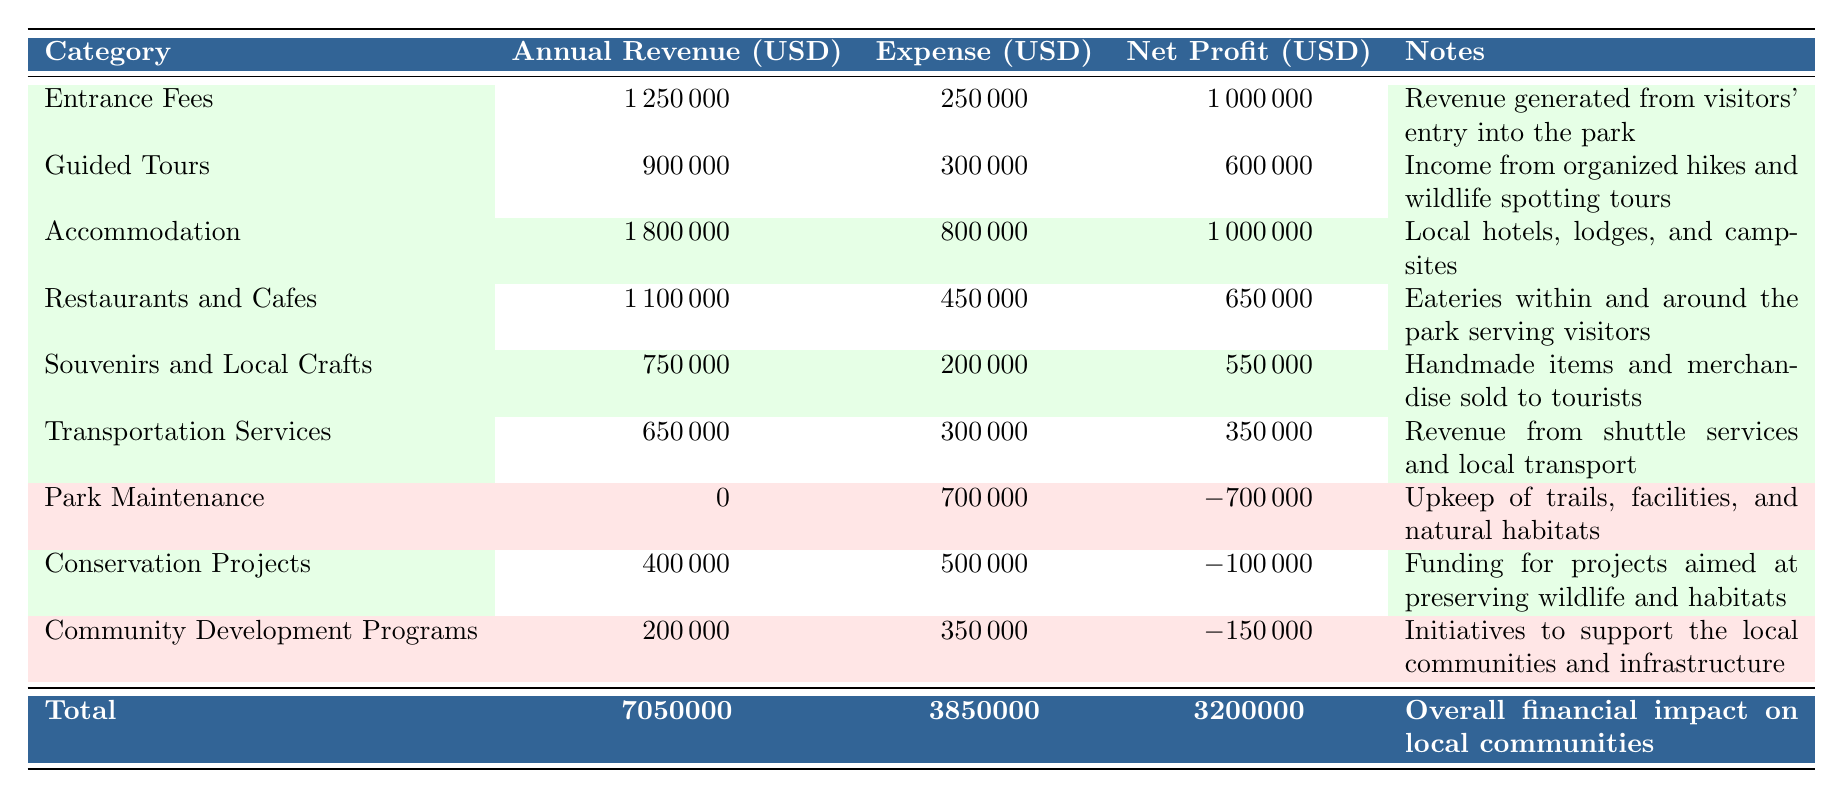What is the annual revenue generated from entrance fees? The table shows that the annual revenue from entrance fees is listed under the "Annual Revenue (USD)" column for the "Entrance Fees" category. The value is 1,250,000 USD.
Answer: 1,250,000 What is the net profit from the guided tours category? Under the "Guided Tours" category, the "Net Profit (USD)" column indicates that the net profit is 600,000 USD.
Answer: 600,000 Which category has the highest annual revenue? By comparing the annual revenues across all categories, the "Accommodation" category has the highest annual revenue of 1,800,000 USD, which is greater than the other categories listed.
Answer: Accommodation Is the total expense for the park maintenance category higher than the total revenue for guided tours? The "Park Maintenance" expense is listed as 700,000 USD while the "Guided Tours" category has an annual revenue of 900,000 USD. Since 700,000 is less than 900,000, the statement is false.
Answer: No What is the net profit from all categories combined? The "Total" row at the bottom of the table provides the combined figures. The net profit is 3,200,000 USD as stated in the "Net Profit (USD)" column for the total.
Answer: 3,200,000 What is the combined annual revenue from the "Souvenirs and Local Crafts" and "Transportation Services" categories? To find the combined revenue, add the annual revenues from both categories: 750,000 (Souvenirs and Local Crafts) + 650,000 (Transportation Services) = 1,400,000 USD.
Answer: 1,400,000 Are the total expenses more than the total revenues in the provided table? The total expenses listed in the "Total" row is 3,850,000 USD while the total revenues is 7,050,000 USD, indicating that the total revenues exceed the total expenses; therefore, the statement is false.
Answer: No Which category experiences a net loss? The table lists categories with their respective net profits or losses. The categories "Park Maintenance," "Conservation Projects," and "Community Development Programs" have negative net profits of -700,000, -100,000, and -150,000 USD respectively, indicating they experience net losses.
Answer: Park Maintenance, Conservation Projects, Community Development Programs What would be the average net profit across the categories that generate positive net profit? The categories with positive net profit are "Entrance Fees," "Guided Tours," "Accommodation," "Restaurants and Cafes," "Souvenirs and Local Crafts," and "Transportation Services." Their net profits are 1,000,000, 600,000, 1,000,000, 650,000, 550,000, and 350,000, respectively. Summing these (1,000,000 + 600,000 + 1,000,000 + 650,000 + 550,000 + 350,000 = 4,150,000) and dividing by the number of positive categories (6) gives an average profit of 691,667 USD.
Answer: 691,667 